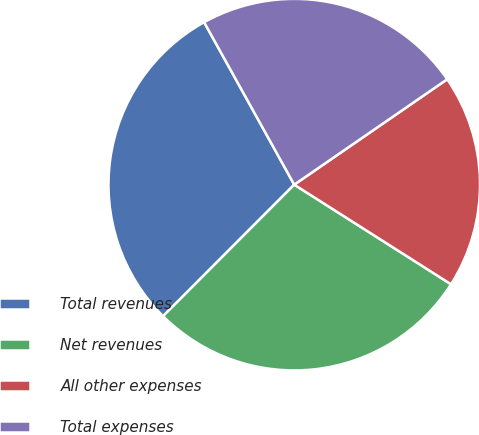<chart> <loc_0><loc_0><loc_500><loc_500><pie_chart><fcel>Total revenues<fcel>Net revenues<fcel>All other expenses<fcel>Total expenses<nl><fcel>29.46%<fcel>28.47%<fcel>18.61%<fcel>23.46%<nl></chart> 